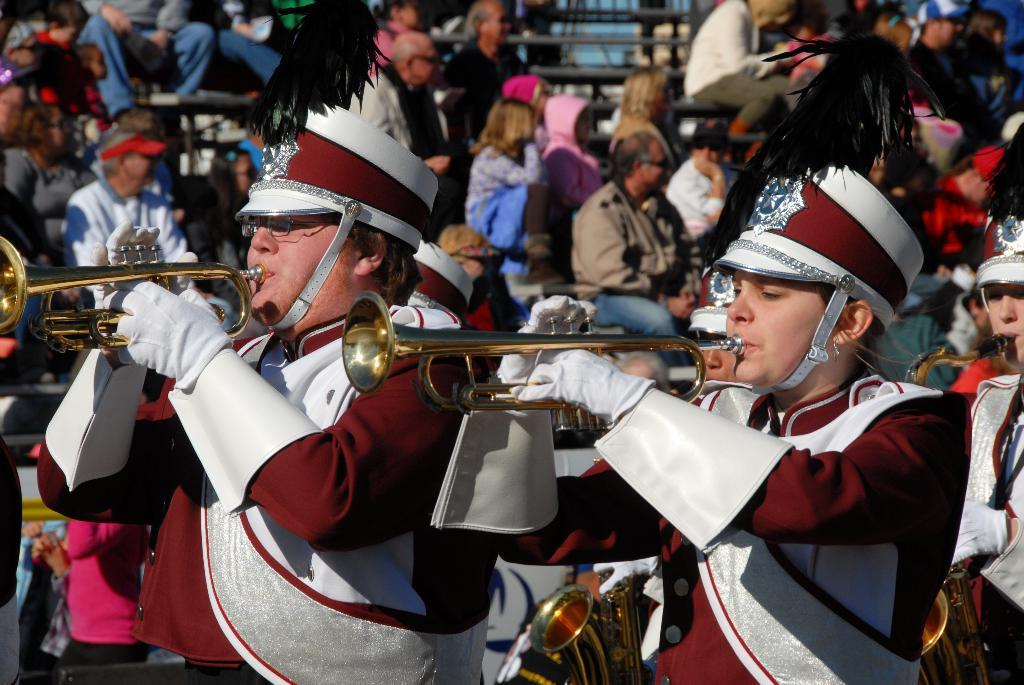What are the people in the image doing? In the image, there are people standing and seated. Some of them are playing trumpets. Can you describe the attire of some people in the image? Some people in the image are wearing caps. What type of musical instruments are being played in the image? Trumpets are being played in the image. What type of farm animals can be heard in the background of the image? There are no farm animals or sounds present in the image. 